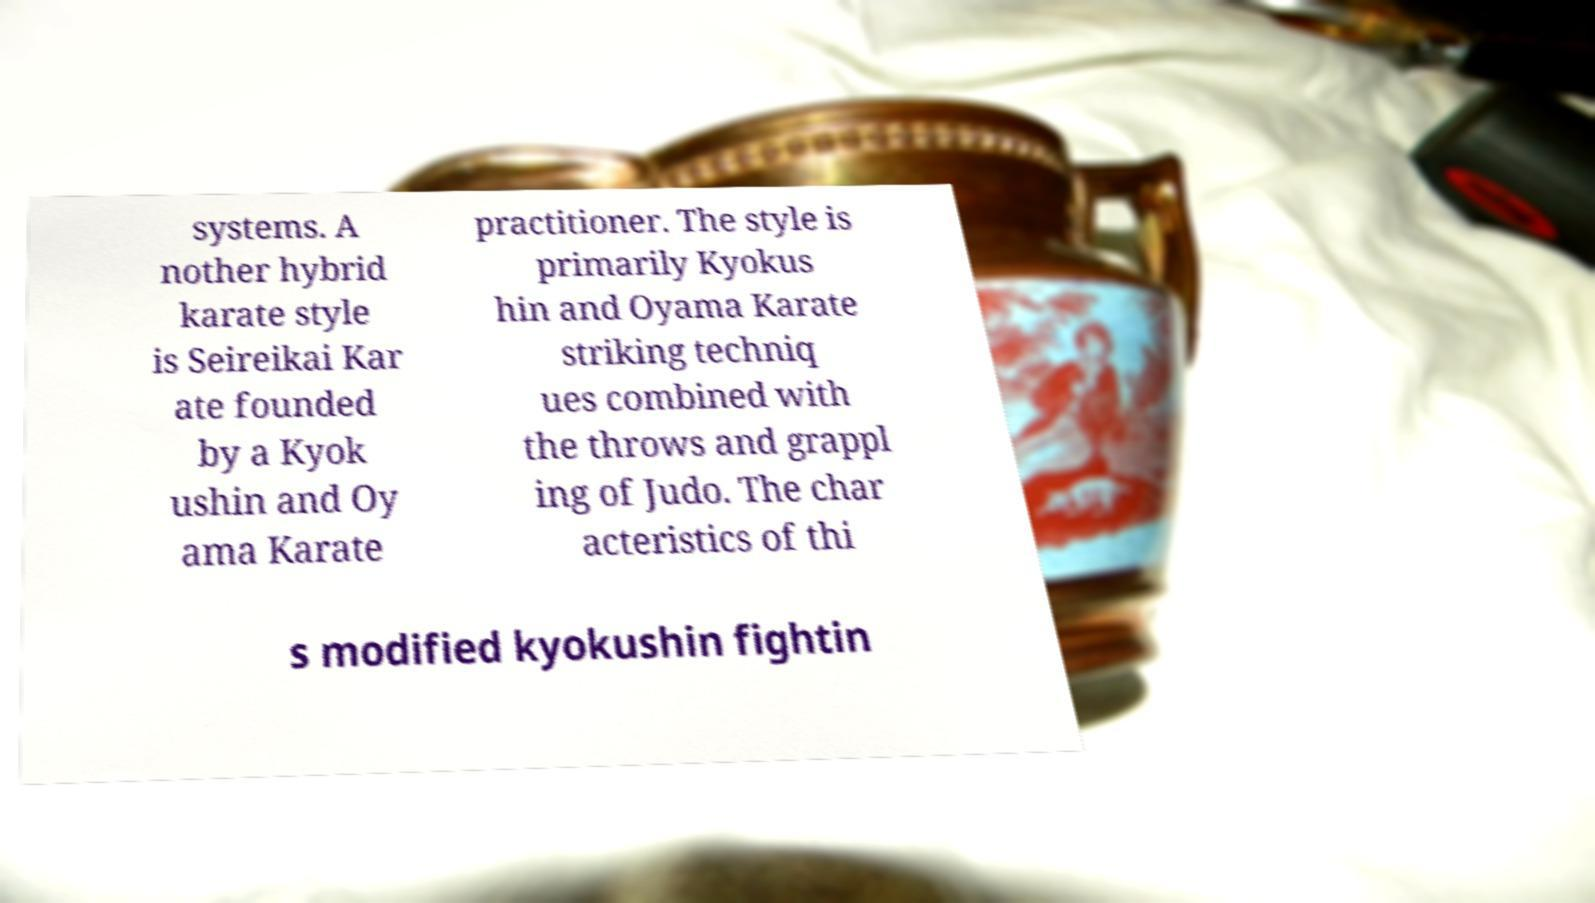For documentation purposes, I need the text within this image transcribed. Could you provide that? systems. A nother hybrid karate style is Seireikai Kar ate founded by a Kyok ushin and Oy ama Karate practitioner. The style is primarily Kyokus hin and Oyama Karate striking techniq ues combined with the throws and grappl ing of Judo. The char acteristics of thi s modified kyokushin fightin 